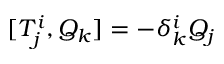<formula> <loc_0><loc_0><loc_500><loc_500>[ T _ { j } ^ { i } , Q _ { k } ] = - \delta _ { k } ^ { i } Q _ { j }</formula> 